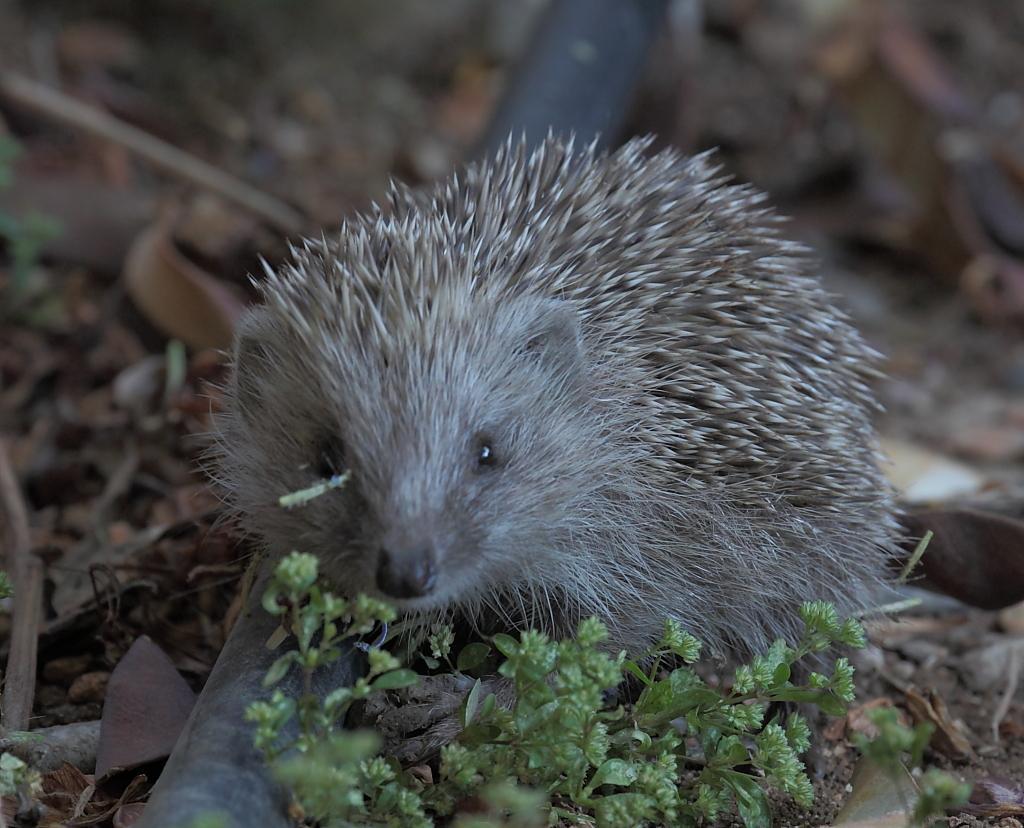Please provide a concise description of this image. In this image we can see a hedgehog on an object. At the bottom of the image there are tiny plants and other objects. In the background of the image there is a blur background. 